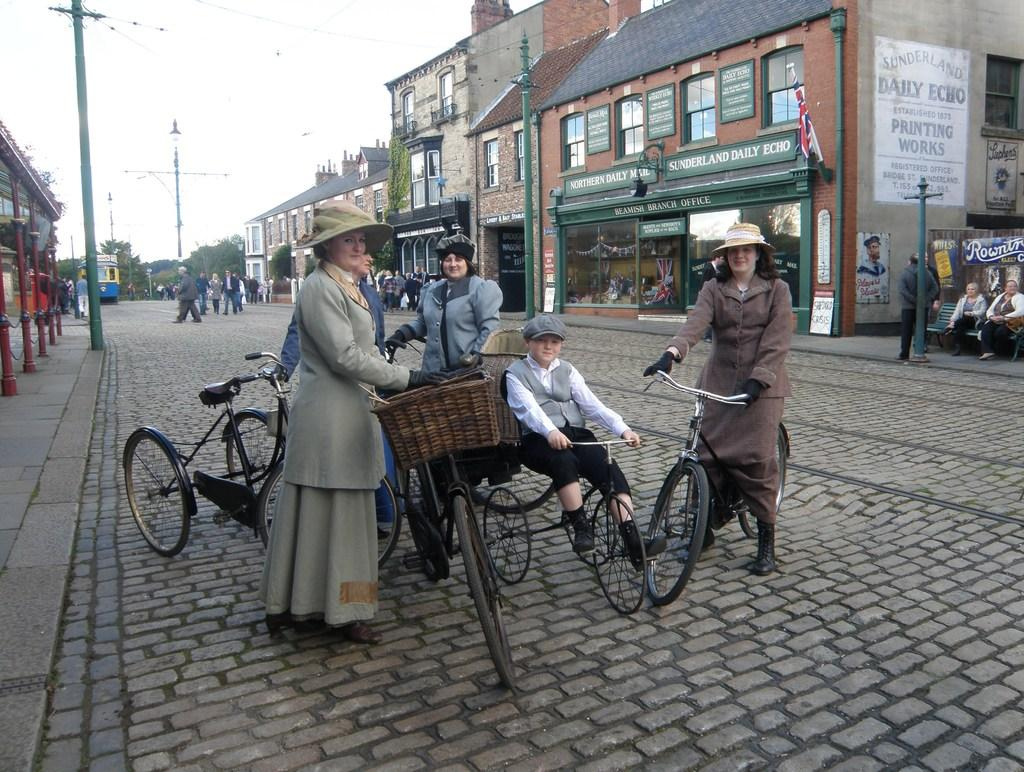How many people are in the image? There are 4 women and a boy in the image, making a total of 5 people. What are the people in the image doing? They are on a path with their cycles. What can be seen in the background of the image? There are buildings and poles in the background of the image. How many people are visible in the background? There are a lot of people in the background of the image. What type of root is being pulled by the boy in the image? There is no root present in the image, and the boy is not pulling anything. 